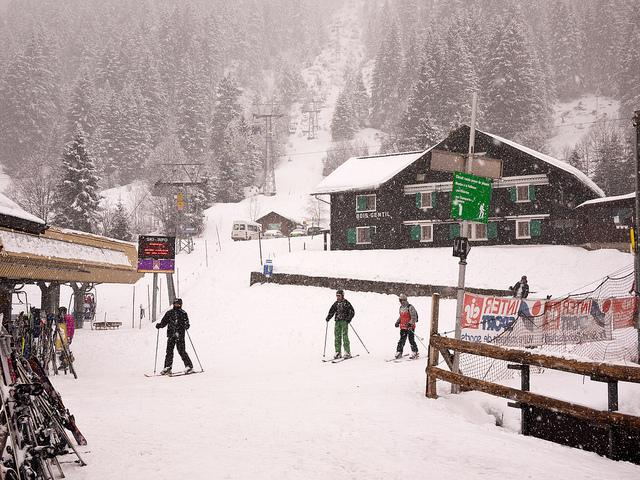What kind of stand is shown? ski stand 